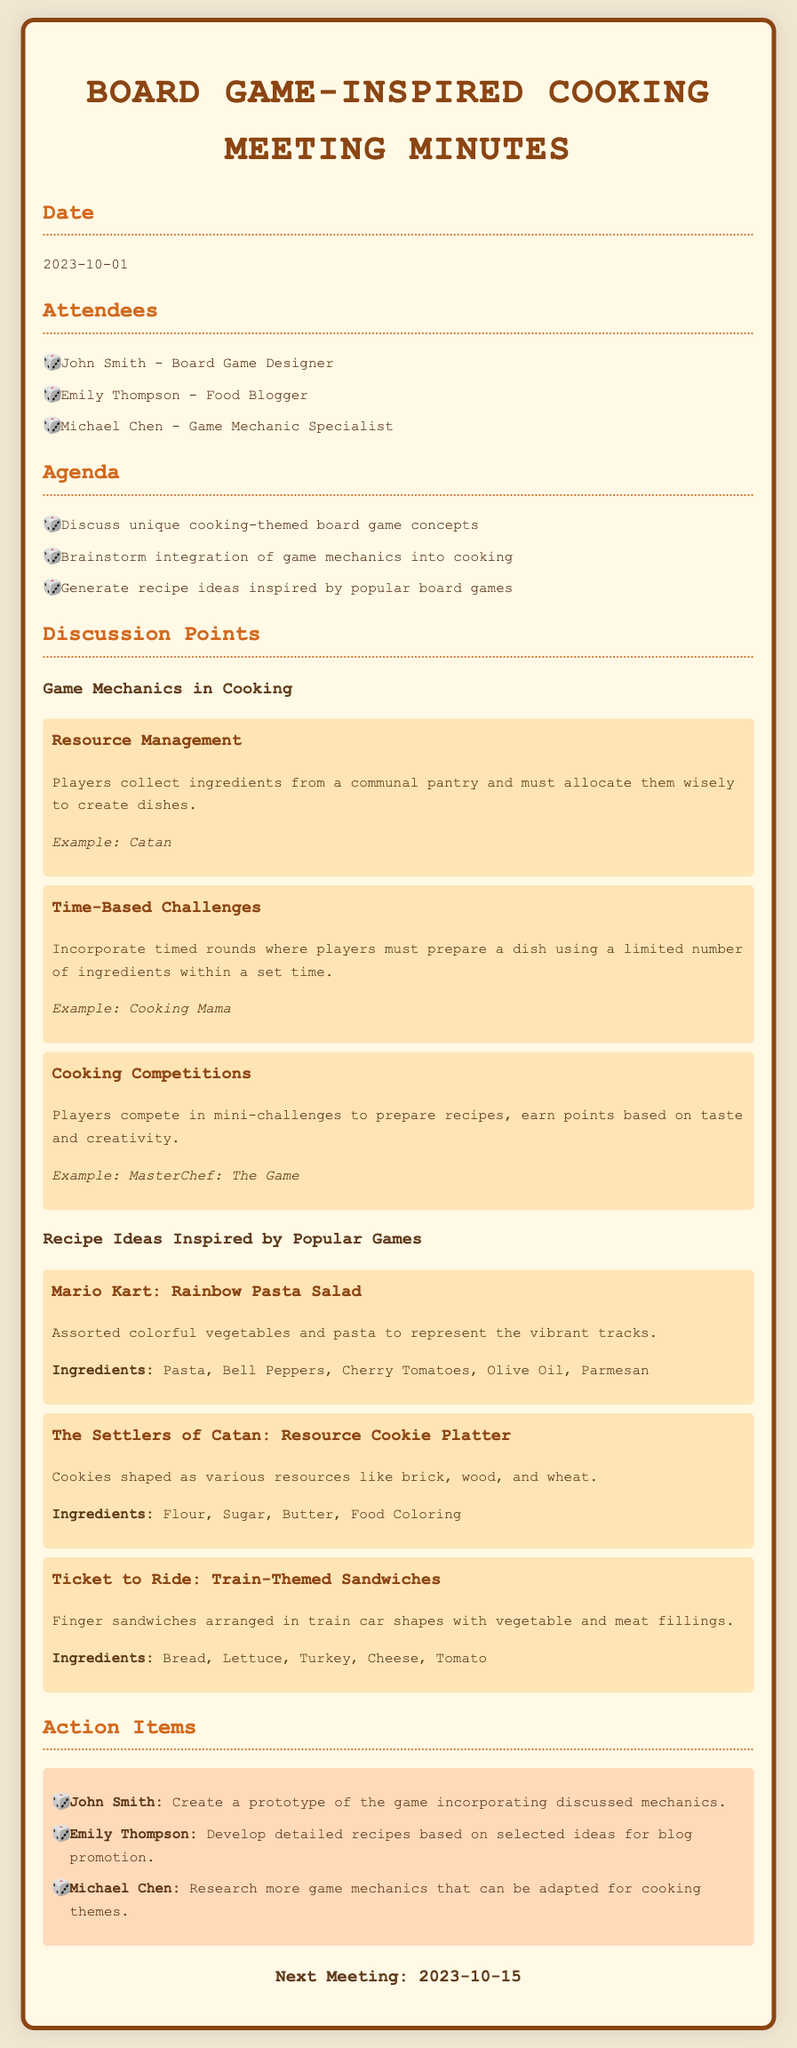What is the date of the meeting? The date of the meeting is specified in the document and is listed as 2023-10-01.
Answer: 2023-10-01 Who is the food blogger attending the meeting? The document lists the attendees, including the food blogger, Emily Thompson.
Answer: Emily Thompson What is one example of a game mechanic discussed in the meeting? The document mentions several mechanics, and one example is Resource Management.
Answer: Resource Management What type of dish is inspired by Mario Kart? The document describes a recipe called Rainbow Pasta Salad inspired by Mario Kart.
Answer: Rainbow Pasta Salad Who is responsible for creating a game prototype? The action items section specifies that John Smith is tasked with creating a game prototype.
Answer: John Smith How many attendees are listed in the document? The document lists three attendees of the meeting.
Answer: Three What is the next meeting date? The next meeting date is mentioned in the document as 2023-10-15.
Answer: 2023-10-15 What type of competition is mentioned as a game mechanic? The document notes Cooking Competitions as a type of game mechanic discussed.
Answer: Cooking Competitions What ingredients are suggested for the Resource Cookie Platter? The document lists Flour, Sugar, Butter, and Food Coloring as ingredients.
Answer: Flour, Sugar, Butter, Food Coloring 